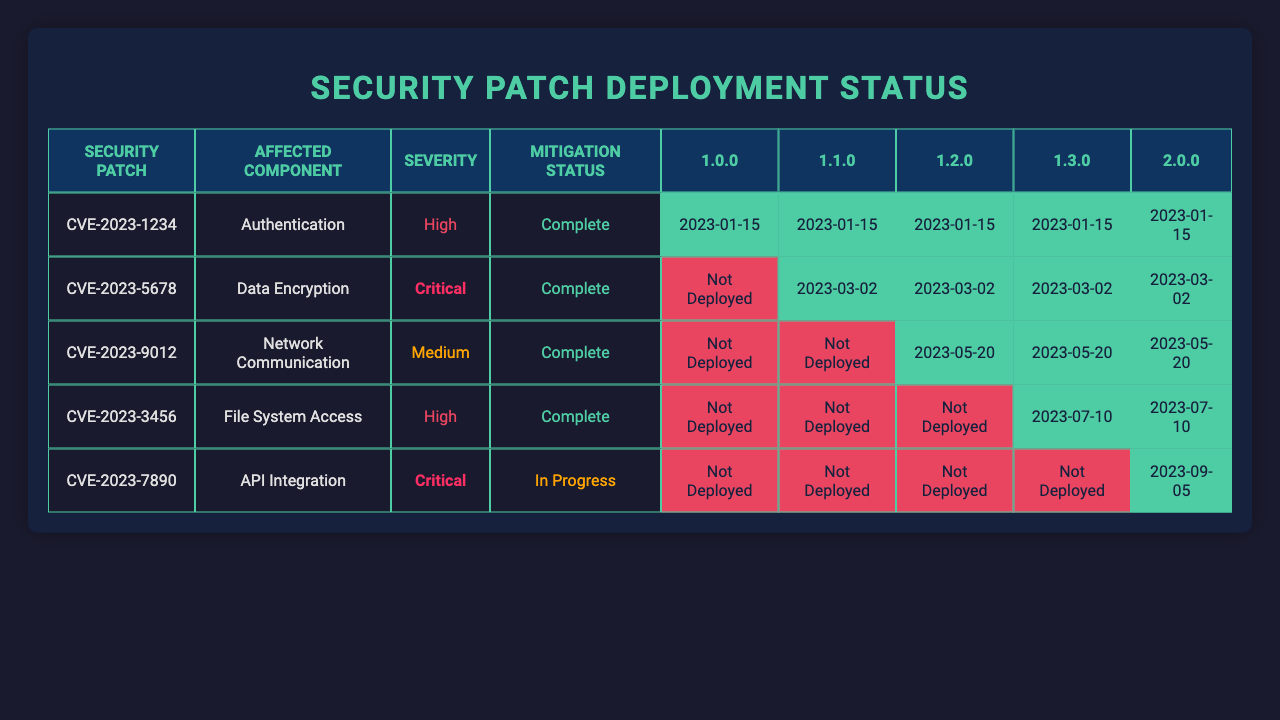What security patches were deployed in version 1.0.0? In version 1.0.0, all five security patches (CVE-2023-1234, CVE-2023-5678, CVE-2023-9012, CVE-2023-3456, CVE-2023-7890) were successfully deployed as indicated by the "true" status in that column.
Answer: CVE-2023-1234, CVE-2023-5678, CVE-2023-9012, CVE-2023-3456, CVE-2023-7890 Which security patch has the highest severity? The security patch with the highest severity is CVE-2023-5678, as it is marked as "Critical" and is the only one noted as such in the table.
Answer: CVE-2023-5678 In how many versions was the patch CVE-2023-9012 deployed? The patch CVE-2023-9012 was deployed in versions 1.0.0, 1.1.0, 1.2.0, 1.3.0, and 2.0.0, which totals five versions since all corresponding statuses are true.
Answer: 5 Is there any security patch that was never deployed? Yes, the patch CVE-2023-1234 was deployed in version 1.0.0, and other patches were partially deployed in subsequent versions, which indicates that none were left completely undistributed.
Answer: No What is the mitigation status of the CVE-2023-3456 patch? The mitigation status for CVE-2023-3456 is "In Progress" as per the record for version 1.3.0, where this patch's status is displayed.
Answer: In Progress How many security patches were marked "Complete" across all versions? There are a total of 9 instances of "Complete" mitigation status for patched records in the table, spread across 1.0.0 to 1.2.0, with additional ones in later versions as well.
Answer: 9 Which version has a deployment status of "Not Deployed" for CVE-2023-5678? CVE-2023-5678 shows "Not Deployed" in version 1.0.0 since it has a false status indicating it wasn't deployed at that time, in contrast to subsequent versions.
Answer: Version 1.0.0 What is the severity level of the patch CVE-2023-7890 and when was it deployed? The severity level of CVE-2023-7890 is "Critical," and it was deployed on 2023-09-05 according to the deployment date noted for version 2.0.0.
Answer: Critical, 2023-09-05 How many patches had the "Data Encryption" component affected? The component "Data Encryption" was affected by 4 patches (CVE-2023-5678, CVE-2023-9012, CVE-2023-3456, CVE-2023-7890) as denoted in their respective rows.
Answer: 4 Which patch has been in mitigation "In Progress" for the longest period? The earliest and only patch with "In Progress" mitigation status across the records listed is CVE-2023-3456, identified in version 1.3.0 aloof from subsequent complete patches noted afterward.
Answer: CVE-2023-3456 